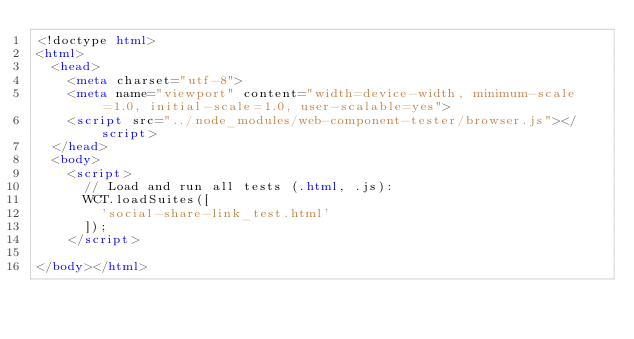<code> <loc_0><loc_0><loc_500><loc_500><_HTML_><!doctype html>
<html>
  <head>
    <meta charset="utf-8">
    <meta name="viewport" content="width=device-width, minimum-scale=1.0, initial-scale=1.0, user-scalable=yes">
    <script src="../node_modules/web-component-tester/browser.js"></script>
  </head>
  <body>
    <script>
      // Load and run all tests (.html, .js):
      WCT.loadSuites([
        'social-share-link_test.html'
      ]);
    </script>

</body></html>
</code> 